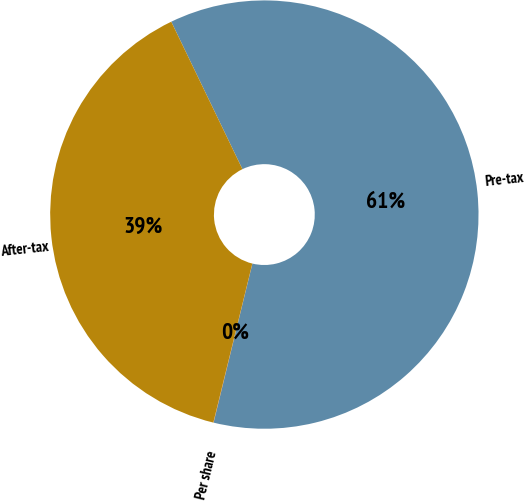<chart> <loc_0><loc_0><loc_500><loc_500><pie_chart><fcel>Pre-tax<fcel>After-tax<fcel>Per share<nl><fcel>60.96%<fcel>39.01%<fcel>0.02%<nl></chart> 